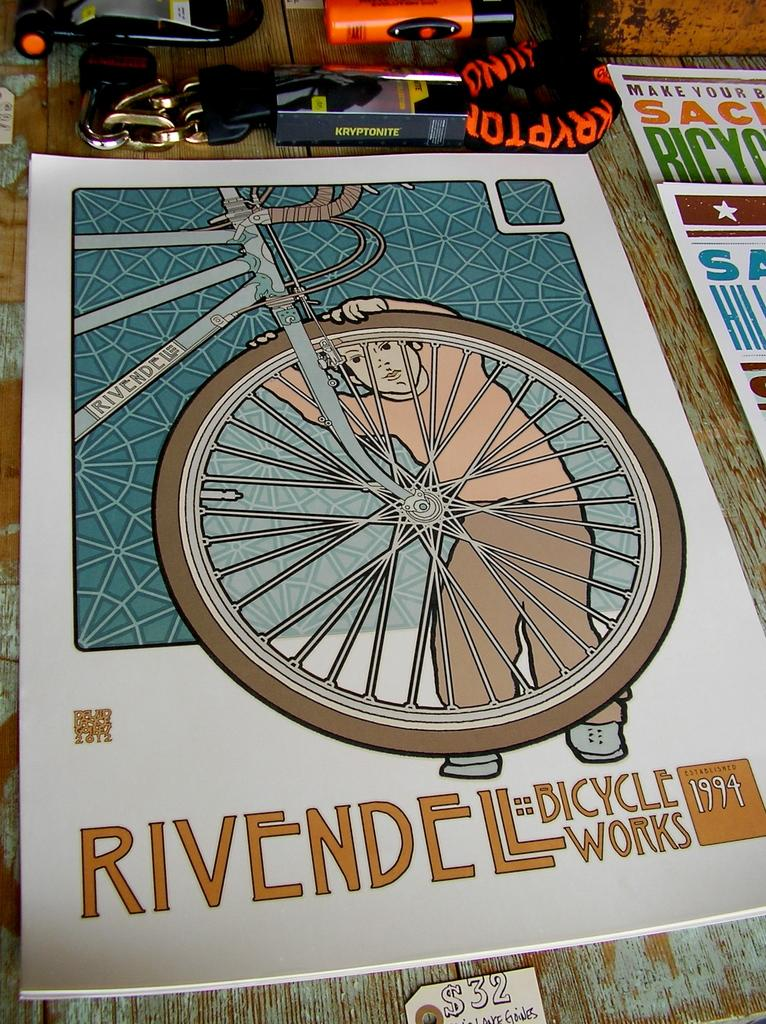What is the main object in the image? There is a book in the image. What else can be seen on the side in the image? There are posters on the side in the image. What is the purpose of the object that looks like a flashlight? There is a torch in the image, which is typically used for providing light in dark environments. What is the chain used for in the image? The chain is present in the image, but its purpose is not clear from the provided facts. What is on the table in the image? There are articles on the table in the image. What information can be found at the bottom of the image? There is a price tag at the bottom of the image. Can you see any docks in the image? There is no mention of a dock in the image, so it cannot be seen. 